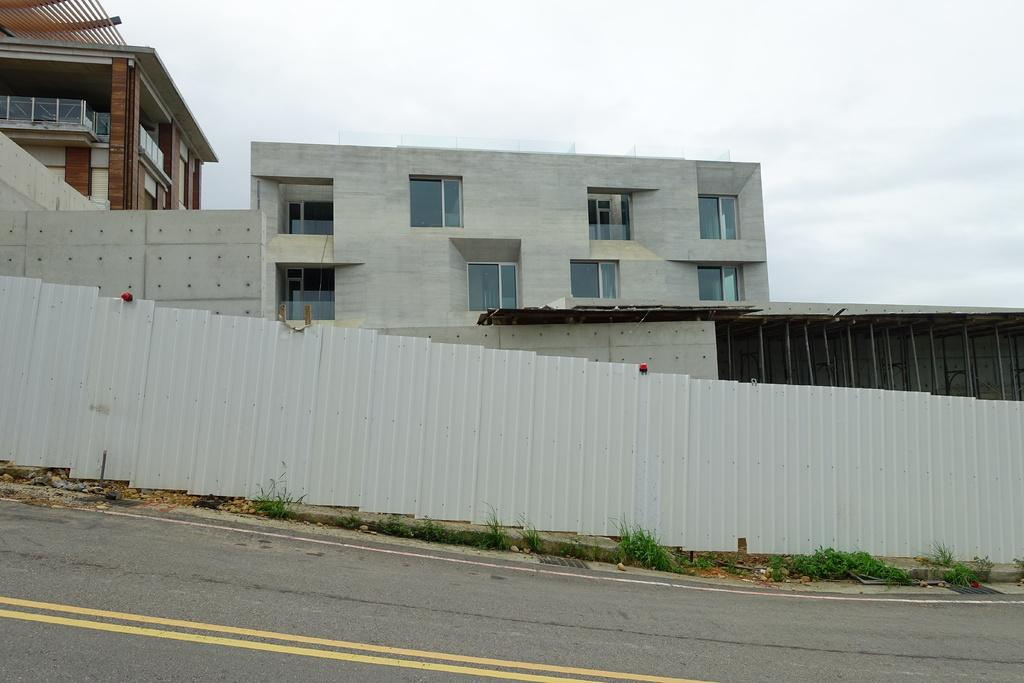What type of structures can be seen in the image? There are buildings in the image. What is located at the bottom of the image? There is a sheet and a road at the bottom of the image. What type of vegetation is present in the image? There is grass in the image. What can be seen in the background of the image? The sky is visible in the background of the image. What type of rhythm can be heard coming from the town in the image? There is no town present in the image, and therefore no rhythm can be heard. 